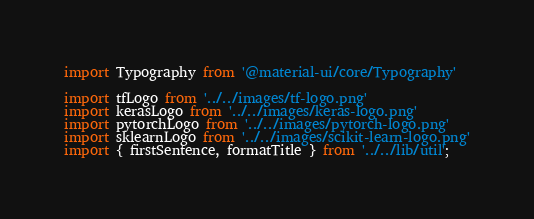Convert code to text. <code><loc_0><loc_0><loc_500><loc_500><_TypeScript_>import Typography from '@material-ui/core/Typography'

import tfLogo from '../../images/tf-logo.png'
import kerasLogo from '../../images/keras-logo.png'
import pytorchLogo from '../../images/pytorch-logo.png'
import sklearnLogo from '../../images/scikit-learn-logo.png'
import { firstSentence, formatTitle } from '../../lib/util';

</code> 